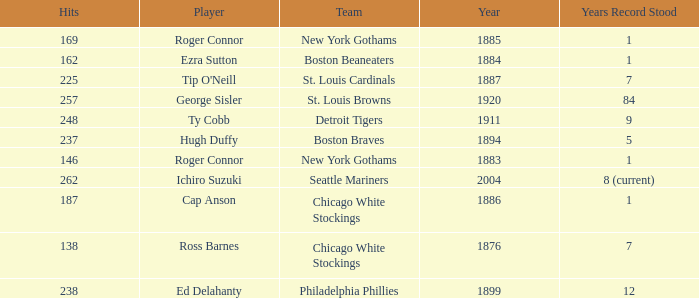Name the least hits for year less than 1920 and player of ed delahanty 238.0. 